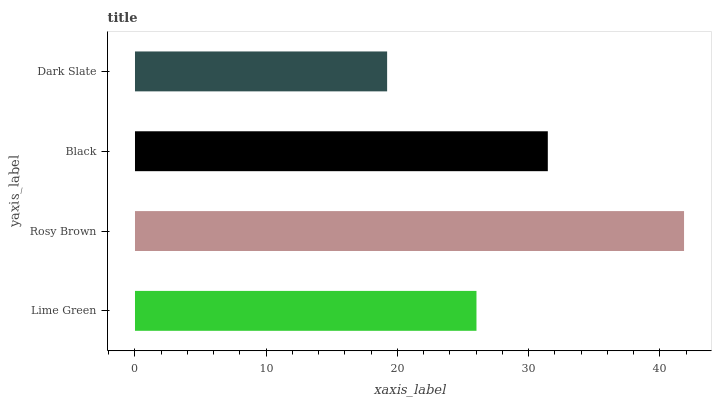Is Dark Slate the minimum?
Answer yes or no. Yes. Is Rosy Brown the maximum?
Answer yes or no. Yes. Is Black the minimum?
Answer yes or no. No. Is Black the maximum?
Answer yes or no. No. Is Rosy Brown greater than Black?
Answer yes or no. Yes. Is Black less than Rosy Brown?
Answer yes or no. Yes. Is Black greater than Rosy Brown?
Answer yes or no. No. Is Rosy Brown less than Black?
Answer yes or no. No. Is Black the high median?
Answer yes or no. Yes. Is Lime Green the low median?
Answer yes or no. Yes. Is Dark Slate the high median?
Answer yes or no. No. Is Rosy Brown the low median?
Answer yes or no. No. 